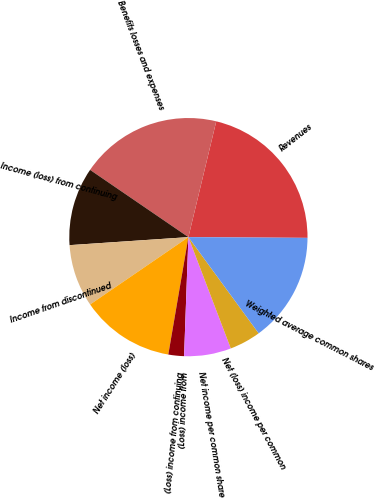Convert chart to OTSL. <chart><loc_0><loc_0><loc_500><loc_500><pie_chart><fcel>Revenues<fcel>Benefits losses and expenses<fcel>Income (loss) from continuing<fcel>Income from discontinued<fcel>Net income (loss)<fcel>(Loss) income from continuing<fcel>(Loss) income from<fcel>Net income per common share<fcel>Net (loss) income per common<fcel>Weighted average common shares<nl><fcel>21.34%<fcel>19.21%<fcel>10.62%<fcel>8.49%<fcel>12.74%<fcel>2.12%<fcel>0.0%<fcel>6.37%<fcel>4.25%<fcel>14.86%<nl></chart> 